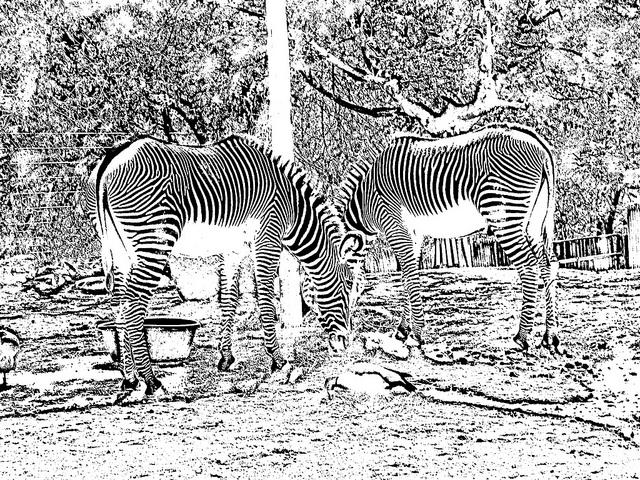How was the photo turned black and white? filters 